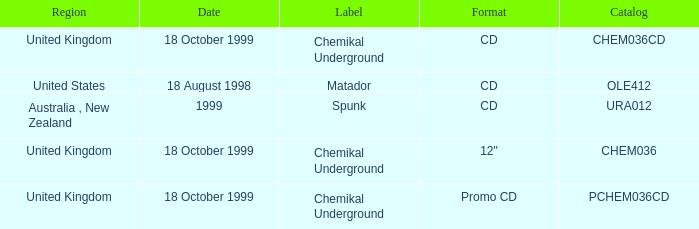What label has a catalog of chem036cd? Chemikal Underground. 